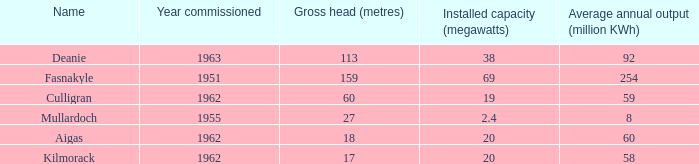What is the Year Commissioned of the power stationo with a Gross head of less than 18? 1962.0. 